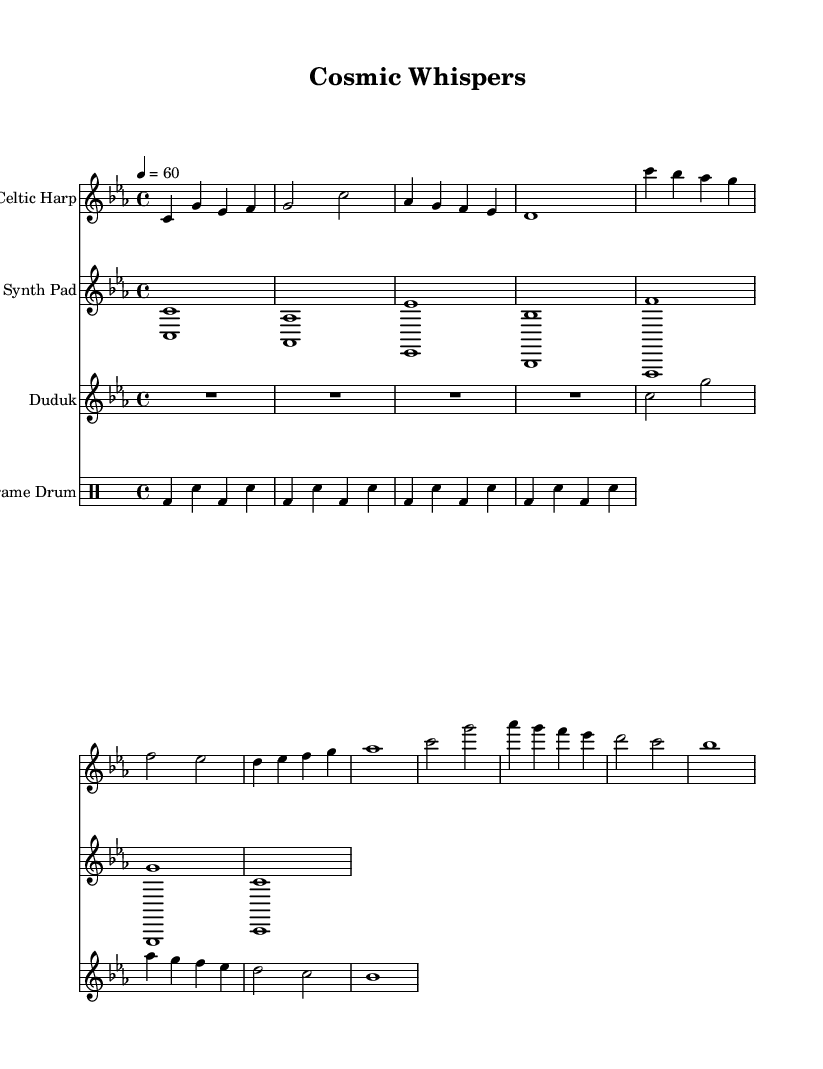What is the key signature of this music? The key signature is indicated at the beginning of the piece. In this case, it is C minor, which has 3 flats (B, E, and A).
Answer: C minor What is the time signature of this music? The time signature appears at the beginning of the music as a fraction, indicating how many beats are in each measure. Here, it is 4/4, meaning there are four beats in each measure.
Answer: 4/4 What tempo marking is given for this piece? The tempo marking is specified with the number that indicates beats per minute. In this case, it states 4 = 60, meaning there are 60 beats in one minute.
Answer: 60 How many bars are in the Celtic Harp section? To determine the number of bars, we can count the groups of notes separated by the vertical lines. The Celtic Harp section has a total of 5 measures.
Answer: 5 Which instrument plays the longest note value in its part? We look at the note values in each instrument's part. The synth pad has whole notes (1) which are the longest note values compared to the other instruments that primarily use shorter note values.
Answer: Synth Pad What type of musical texture can be observed in the combination of the instruments? Examining how different voices and instruments interact, we can see a blend of instrumental timbres with overlapping textures. The combination of a Celtic harp, duduk, synth pad, and frame drum creates a rich, layered, and harmonic texture.
Answer: Polyphonic 